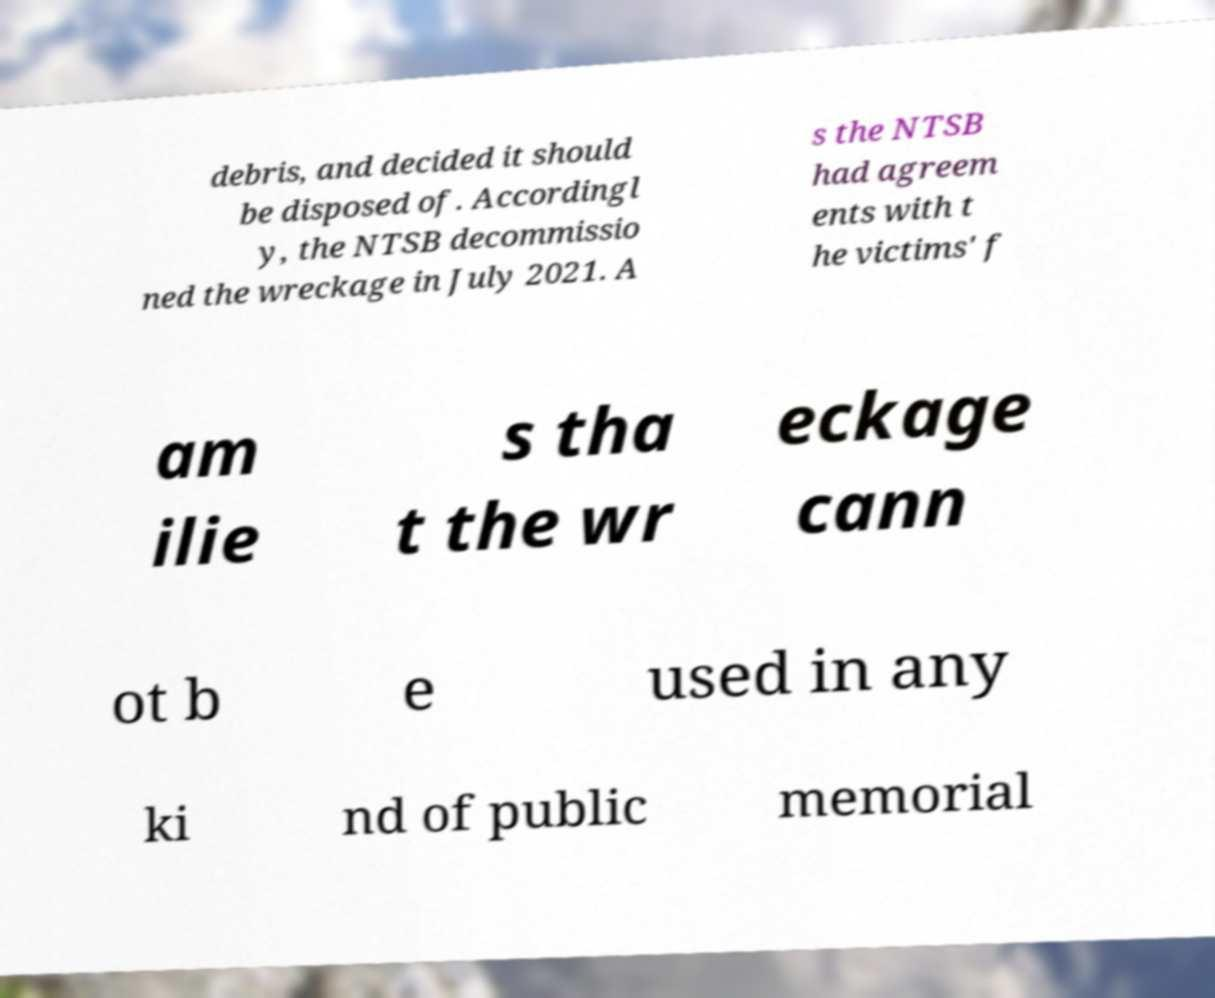Could you extract and type out the text from this image? debris, and decided it should be disposed of. Accordingl y, the NTSB decommissio ned the wreckage in July 2021. A s the NTSB had agreem ents with t he victims' f am ilie s tha t the wr eckage cann ot b e used in any ki nd of public memorial 